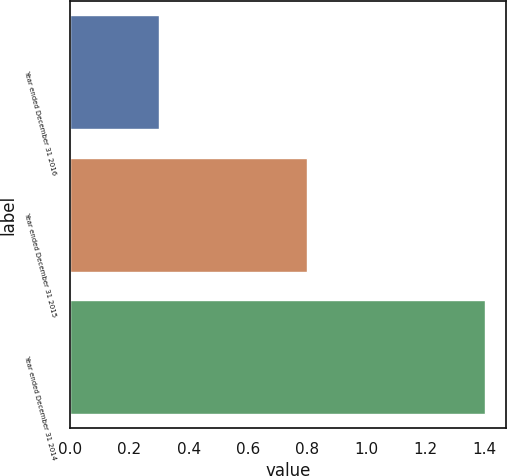Convert chart to OTSL. <chart><loc_0><loc_0><loc_500><loc_500><bar_chart><fcel>Year ended December 31 2016<fcel>Year ended December 31 2015<fcel>Year ended December 31 2014<nl><fcel>0.3<fcel>0.8<fcel>1.4<nl></chart> 